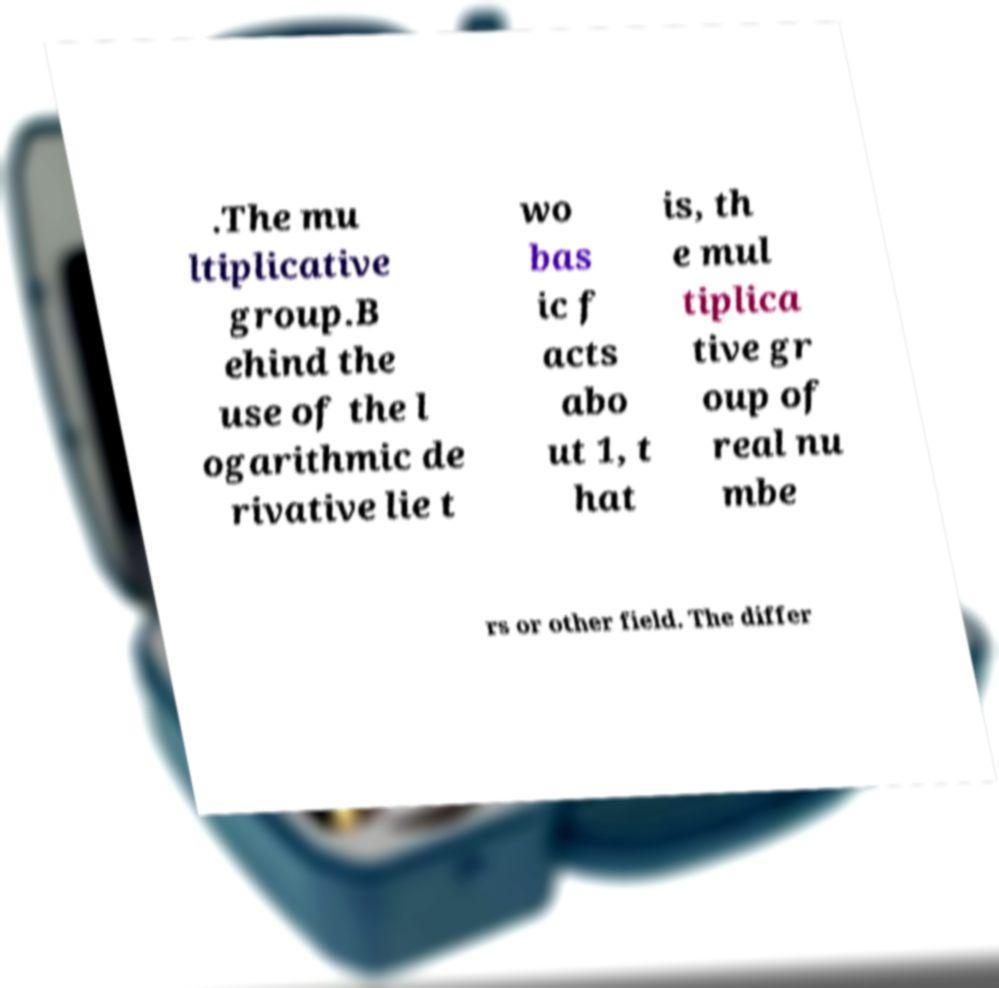There's text embedded in this image that I need extracted. Can you transcribe it verbatim? .The mu ltiplicative group.B ehind the use of the l ogarithmic de rivative lie t wo bas ic f acts abo ut 1, t hat is, th e mul tiplica tive gr oup of real nu mbe rs or other field. The differ 